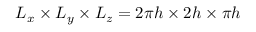Convert formula to latex. <formula><loc_0><loc_0><loc_500><loc_500>L _ { x } \times L _ { y } \times L _ { z } = 2 \pi h \times 2 h \times \pi h</formula> 